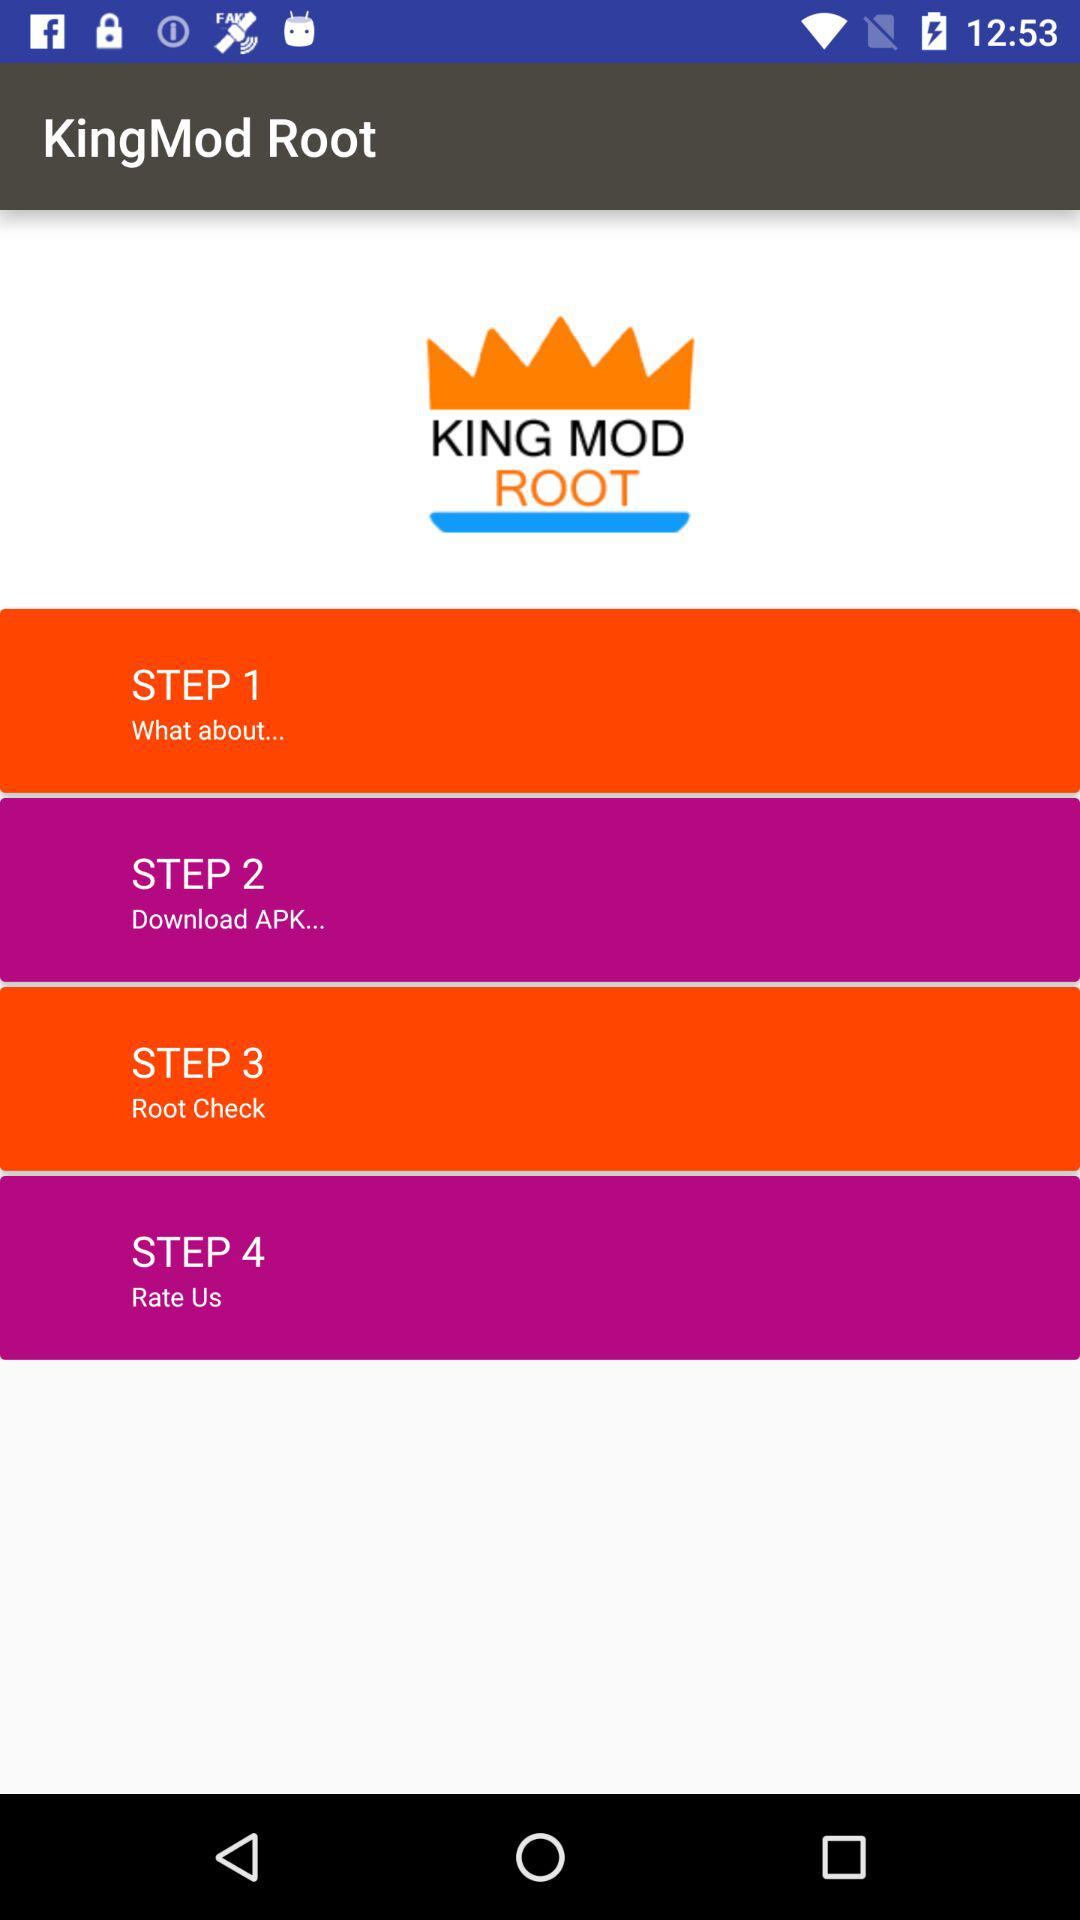How many steps are there in the process?
Answer the question using a single word or phrase. 4 